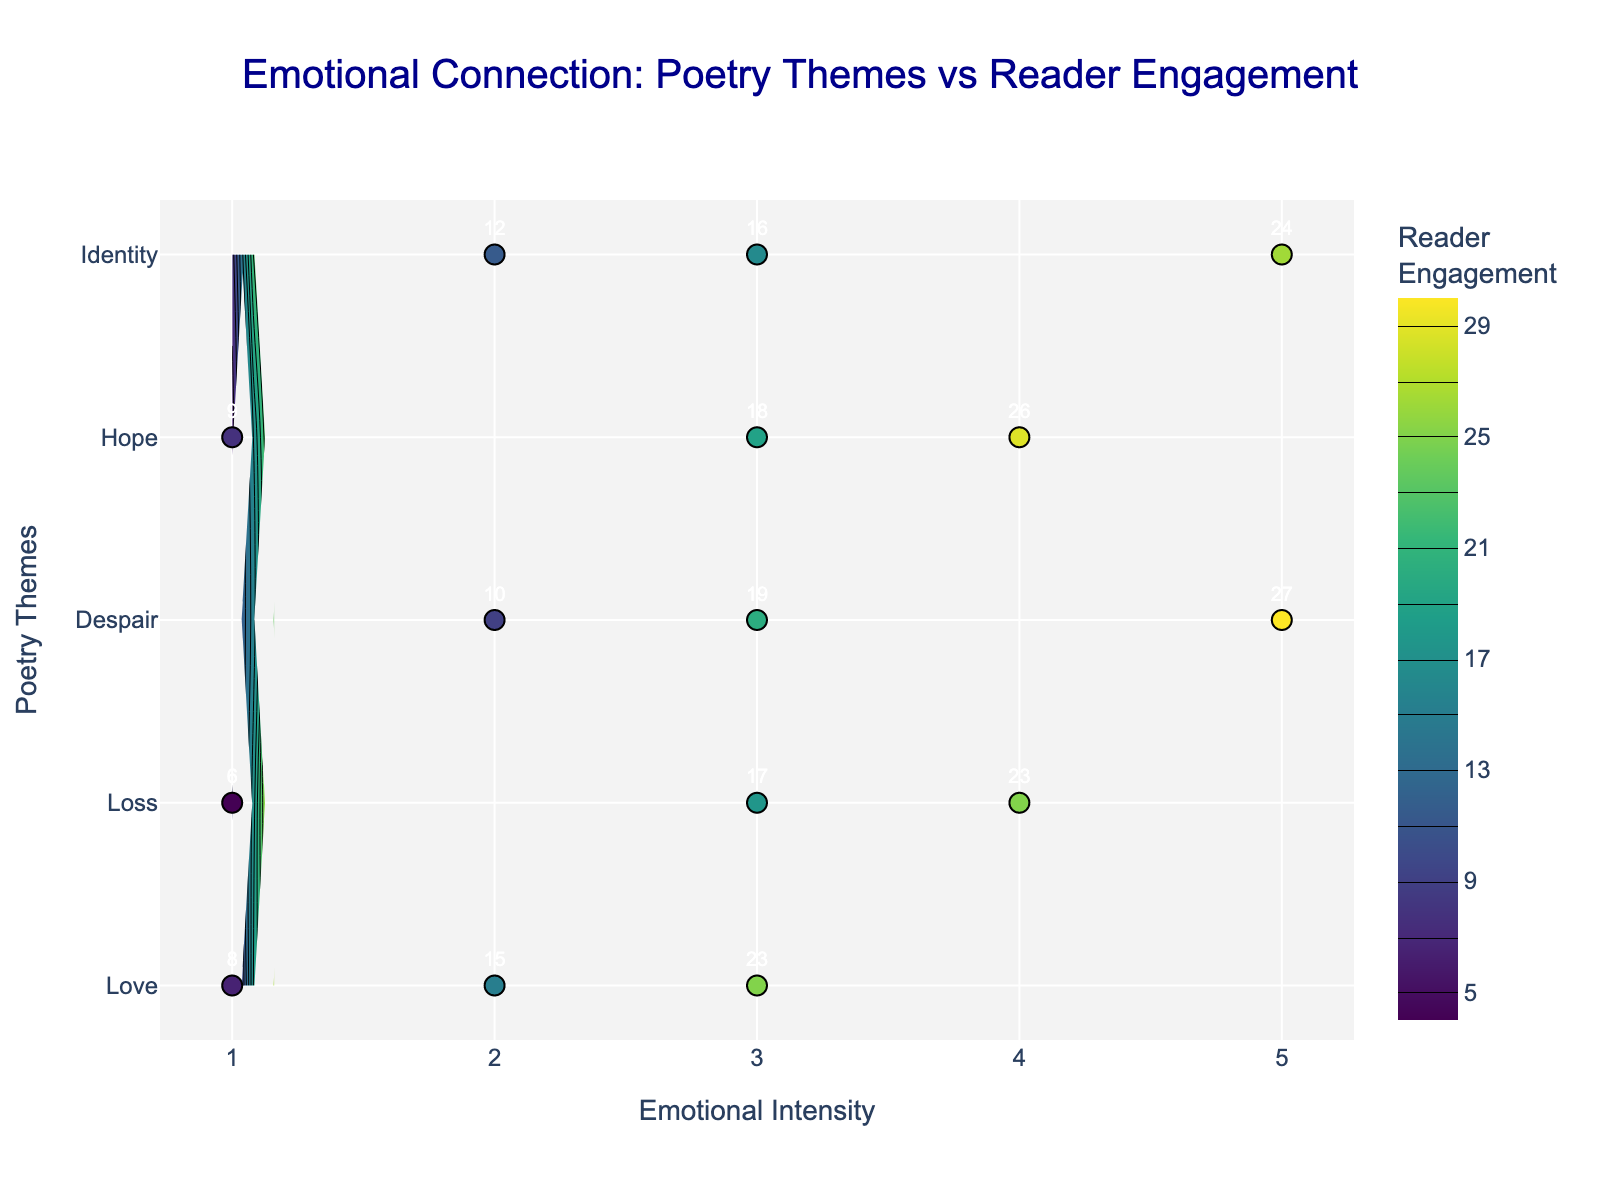What is the title of the plot? The title is typically located at the top center of the plot. It usually encapsulates the main theme or purpose of the visual representation.
Answer: Emotional Connection: Poetry Themes vs Reader Engagement What axis represents the poetry themes? Examine the y-axis to determine what variable it is referencing.
Answer: Y-axis How many data points are there for the theme "Love"? Looking directly at the plot, count each instance of a "Love" data point along the y-axis and its corresponding markers.
Answer: 3 Which theme has the highest engagement at intensity 5? Identify the y-axis label corresponding to intensity 5 on the x-axis where engagement is the highest.
Answer: Despair What's the total engagement for the theme "Hope" across all intensities? Sum all the engagement values for "Hope." These are labeled on the markers on the plot.
Answer: 9 + 18 + 26 = 53 Which theme shows a peak in engagement at intensity 2? Check which theme on the y-axis displays the highest engagement marker at intensity 2.
Answer: Identity Compare the engagement at intensity 4 for "Loss" and "Hope". Which is higher? Directly compare the engagement values for these themes at intensity 4.
Answer: Hope For the theme "Despair," what is the difference in engagement between intensity 5 and intensity 2? Subtract the engagement at intensity 2 from that at intensity 5 for "Despair."
Answer: 27 - 10 = 17 What color in the contour plot indicates the highest engagement? Identify the color associated with the highest readings in the color scale provided on the plot.
Answer: Dark yellow Which theme has the most drastic change in engagement across different intensities? Evaluate the fluctuation of engagement values for each theme and determine the one with the most significant variance.
Answer: Despair 